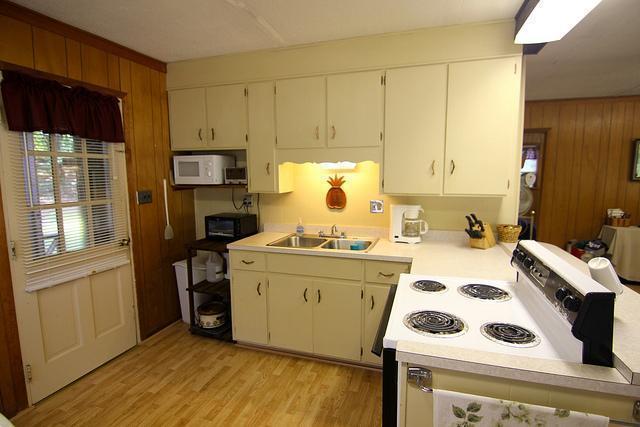How is the kitchen counter by the stove illuminated?
Indicate the correct choice and explain in the format: 'Answer: answer
Rationale: rationale.'
Options: Led light, incandescent light, halogen light, fluorescent light. Answer: fluorescent light.
Rationale: There is a light on the ceiling 